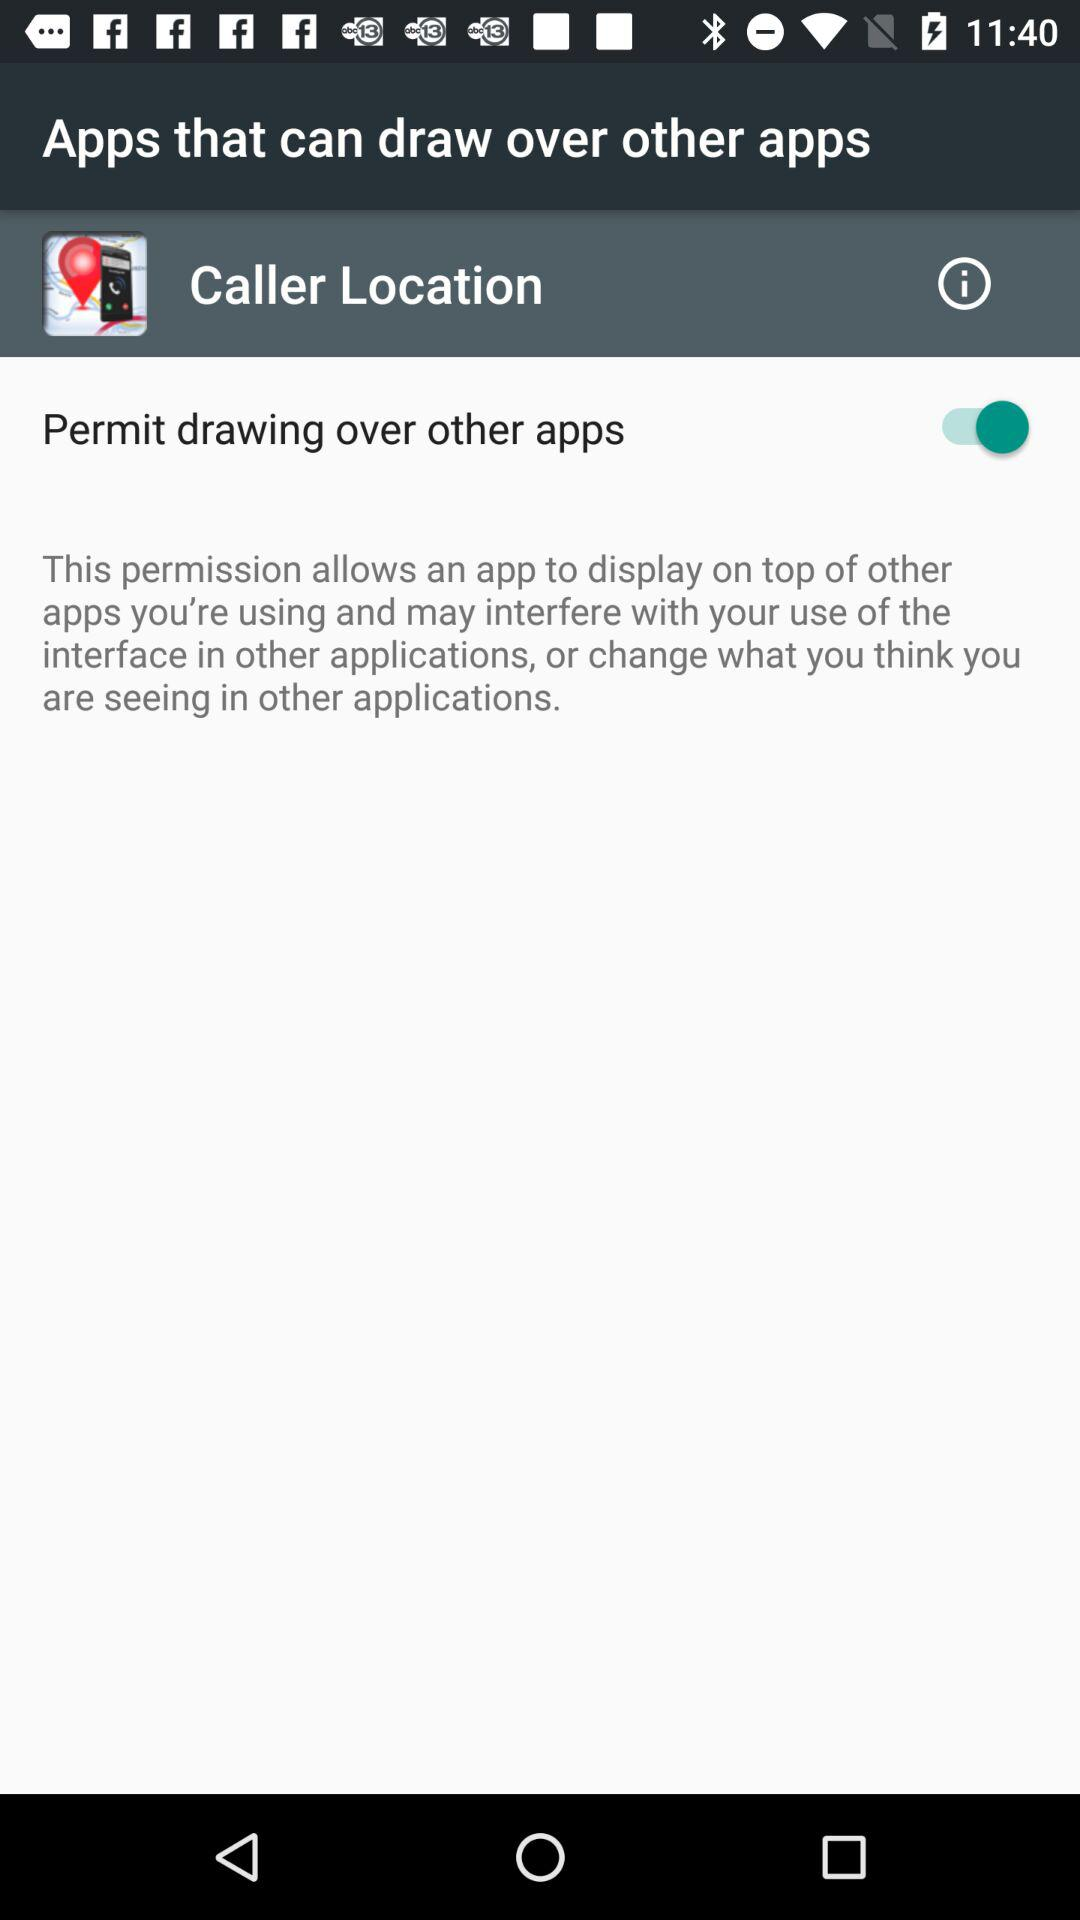What is the caller's location?
When the provided information is insufficient, respond with <no answer>. <no answer> 